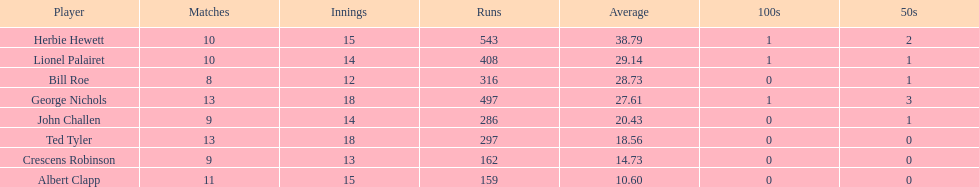What were the number of innings albert clapp had? 15. 